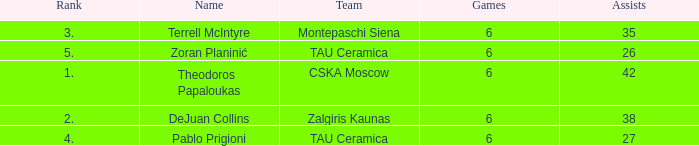What is the least number of assists among players ranked 2? 38.0. 